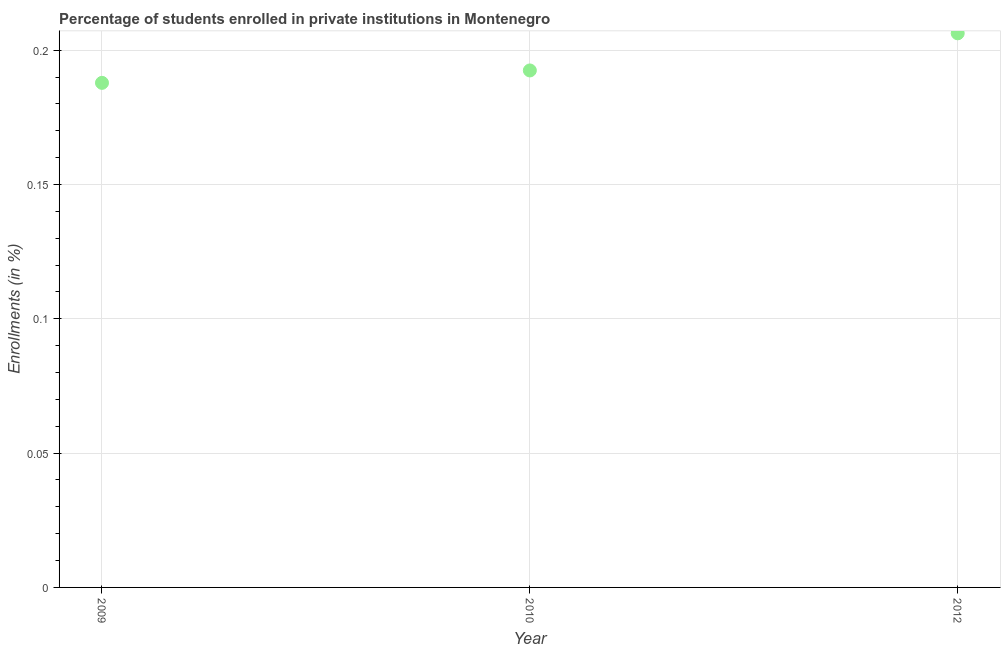What is the enrollments in private institutions in 2012?
Provide a short and direct response. 0.21. Across all years, what is the maximum enrollments in private institutions?
Your answer should be compact. 0.21. Across all years, what is the minimum enrollments in private institutions?
Provide a short and direct response. 0.19. In which year was the enrollments in private institutions minimum?
Provide a short and direct response. 2009. What is the sum of the enrollments in private institutions?
Make the answer very short. 0.59. What is the difference between the enrollments in private institutions in 2009 and 2012?
Make the answer very short. -0.02. What is the average enrollments in private institutions per year?
Your response must be concise. 0.2. What is the median enrollments in private institutions?
Offer a terse response. 0.19. Do a majority of the years between 2009 and 2012 (inclusive) have enrollments in private institutions greater than 0.11 %?
Offer a very short reply. Yes. What is the ratio of the enrollments in private institutions in 2010 to that in 2012?
Your answer should be compact. 0.93. Is the enrollments in private institutions in 2010 less than that in 2012?
Provide a short and direct response. Yes. What is the difference between the highest and the second highest enrollments in private institutions?
Your answer should be compact. 0.01. Is the sum of the enrollments in private institutions in 2009 and 2010 greater than the maximum enrollments in private institutions across all years?
Your answer should be very brief. Yes. What is the difference between the highest and the lowest enrollments in private institutions?
Your response must be concise. 0.02. Does the enrollments in private institutions monotonically increase over the years?
Your response must be concise. Yes. How many dotlines are there?
Your answer should be compact. 1. How many years are there in the graph?
Provide a succinct answer. 3. What is the difference between two consecutive major ticks on the Y-axis?
Your response must be concise. 0.05. Are the values on the major ticks of Y-axis written in scientific E-notation?
Offer a terse response. No. Does the graph contain grids?
Offer a very short reply. Yes. What is the title of the graph?
Offer a very short reply. Percentage of students enrolled in private institutions in Montenegro. What is the label or title of the Y-axis?
Provide a succinct answer. Enrollments (in %). What is the Enrollments (in %) in 2009?
Your response must be concise. 0.19. What is the Enrollments (in %) in 2010?
Provide a short and direct response. 0.19. What is the Enrollments (in %) in 2012?
Your answer should be compact. 0.21. What is the difference between the Enrollments (in %) in 2009 and 2010?
Provide a short and direct response. -0. What is the difference between the Enrollments (in %) in 2009 and 2012?
Provide a short and direct response. -0.02. What is the difference between the Enrollments (in %) in 2010 and 2012?
Offer a very short reply. -0.01. What is the ratio of the Enrollments (in %) in 2009 to that in 2012?
Make the answer very short. 0.91. What is the ratio of the Enrollments (in %) in 2010 to that in 2012?
Your answer should be very brief. 0.93. 